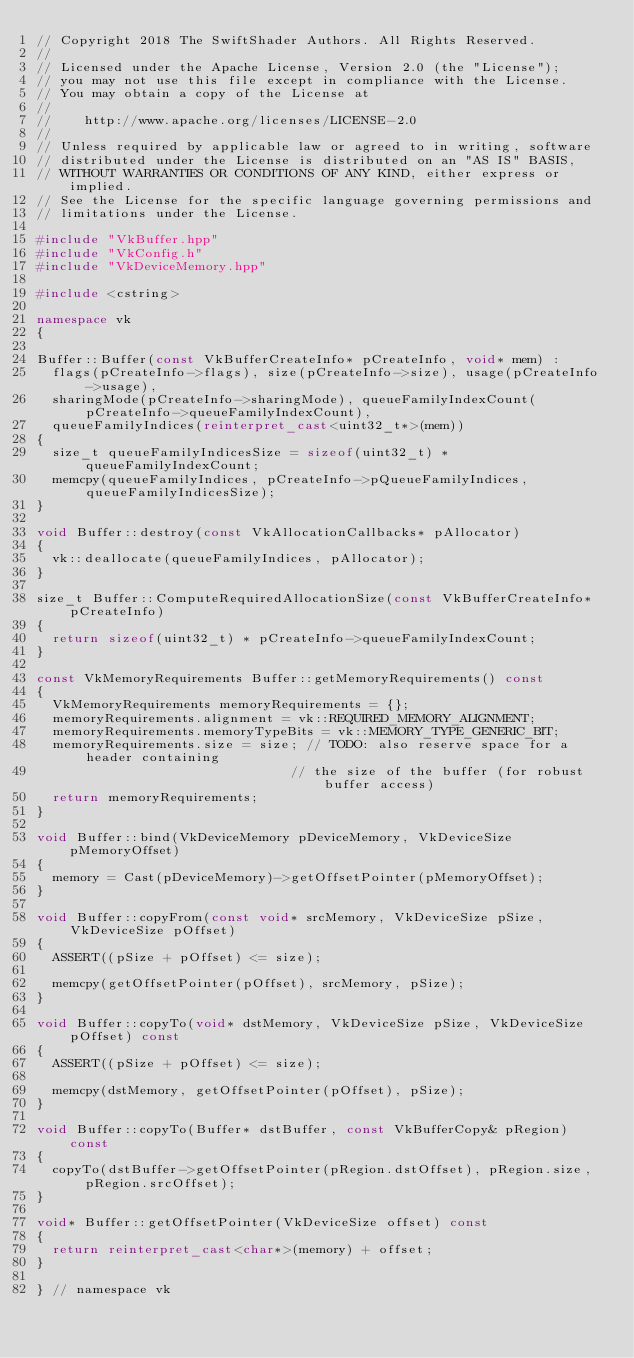Convert code to text. <code><loc_0><loc_0><loc_500><loc_500><_C++_>// Copyright 2018 The SwiftShader Authors. All Rights Reserved.
//
// Licensed under the Apache License, Version 2.0 (the "License");
// you may not use this file except in compliance with the License.
// You may obtain a copy of the License at
//
//    http://www.apache.org/licenses/LICENSE-2.0
//
// Unless required by applicable law or agreed to in writing, software
// distributed under the License is distributed on an "AS IS" BASIS,
// WITHOUT WARRANTIES OR CONDITIONS OF ANY KIND, either express or implied.
// See the License for the specific language governing permissions and
// limitations under the License.

#include "VkBuffer.hpp"
#include "VkConfig.h"
#include "VkDeviceMemory.hpp"

#include <cstring>

namespace vk
{

Buffer::Buffer(const VkBufferCreateInfo* pCreateInfo, void* mem) :
	flags(pCreateInfo->flags), size(pCreateInfo->size), usage(pCreateInfo->usage),
	sharingMode(pCreateInfo->sharingMode), queueFamilyIndexCount(pCreateInfo->queueFamilyIndexCount),
	queueFamilyIndices(reinterpret_cast<uint32_t*>(mem))
{
	size_t queueFamilyIndicesSize = sizeof(uint32_t) * queueFamilyIndexCount;
	memcpy(queueFamilyIndices, pCreateInfo->pQueueFamilyIndices, queueFamilyIndicesSize);
}

void Buffer::destroy(const VkAllocationCallbacks* pAllocator)
{
	vk::deallocate(queueFamilyIndices, pAllocator);
}

size_t Buffer::ComputeRequiredAllocationSize(const VkBufferCreateInfo* pCreateInfo)
{
	return sizeof(uint32_t) * pCreateInfo->queueFamilyIndexCount;
}

const VkMemoryRequirements Buffer::getMemoryRequirements() const
{
	VkMemoryRequirements memoryRequirements = {};
	memoryRequirements.alignment = vk::REQUIRED_MEMORY_ALIGNMENT;
	memoryRequirements.memoryTypeBits = vk::MEMORY_TYPE_GENERIC_BIT;
	memoryRequirements.size = size; // TODO: also reserve space for a header containing
		                            // the size of the buffer (for robust buffer access)
	return memoryRequirements;
}

void Buffer::bind(VkDeviceMemory pDeviceMemory, VkDeviceSize pMemoryOffset)
{
	memory = Cast(pDeviceMemory)->getOffsetPointer(pMemoryOffset);
}

void Buffer::copyFrom(const void* srcMemory, VkDeviceSize pSize, VkDeviceSize pOffset)
{
	ASSERT((pSize + pOffset) <= size);

	memcpy(getOffsetPointer(pOffset), srcMemory, pSize);
}

void Buffer::copyTo(void* dstMemory, VkDeviceSize pSize, VkDeviceSize pOffset) const
{
	ASSERT((pSize + pOffset) <= size);

	memcpy(dstMemory, getOffsetPointer(pOffset), pSize);
}

void Buffer::copyTo(Buffer* dstBuffer, const VkBufferCopy& pRegion) const
{
	copyTo(dstBuffer->getOffsetPointer(pRegion.dstOffset), pRegion.size, pRegion.srcOffset);
}

void* Buffer::getOffsetPointer(VkDeviceSize offset) const
{
	return reinterpret_cast<char*>(memory) + offset;
}

} // namespace vk
</code> 